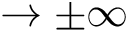Convert formula to latex. <formula><loc_0><loc_0><loc_500><loc_500>\rightarrow \pm \infty</formula> 